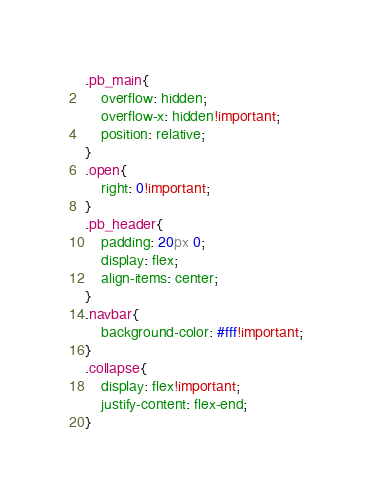<code> <loc_0><loc_0><loc_500><loc_500><_CSS_>.pb_main{
    overflow: hidden;
    overflow-x: hidden!important;
    position: relative;
}
.open{
    right: 0!important;
}
.pb_header{
    padding: 20px 0;
    display: flex;
    align-items: center;
}
.navbar{
    background-color: #fff!important;
}
.collapse{
    display: flex!important;
    justify-content: flex-end;
}</code> 